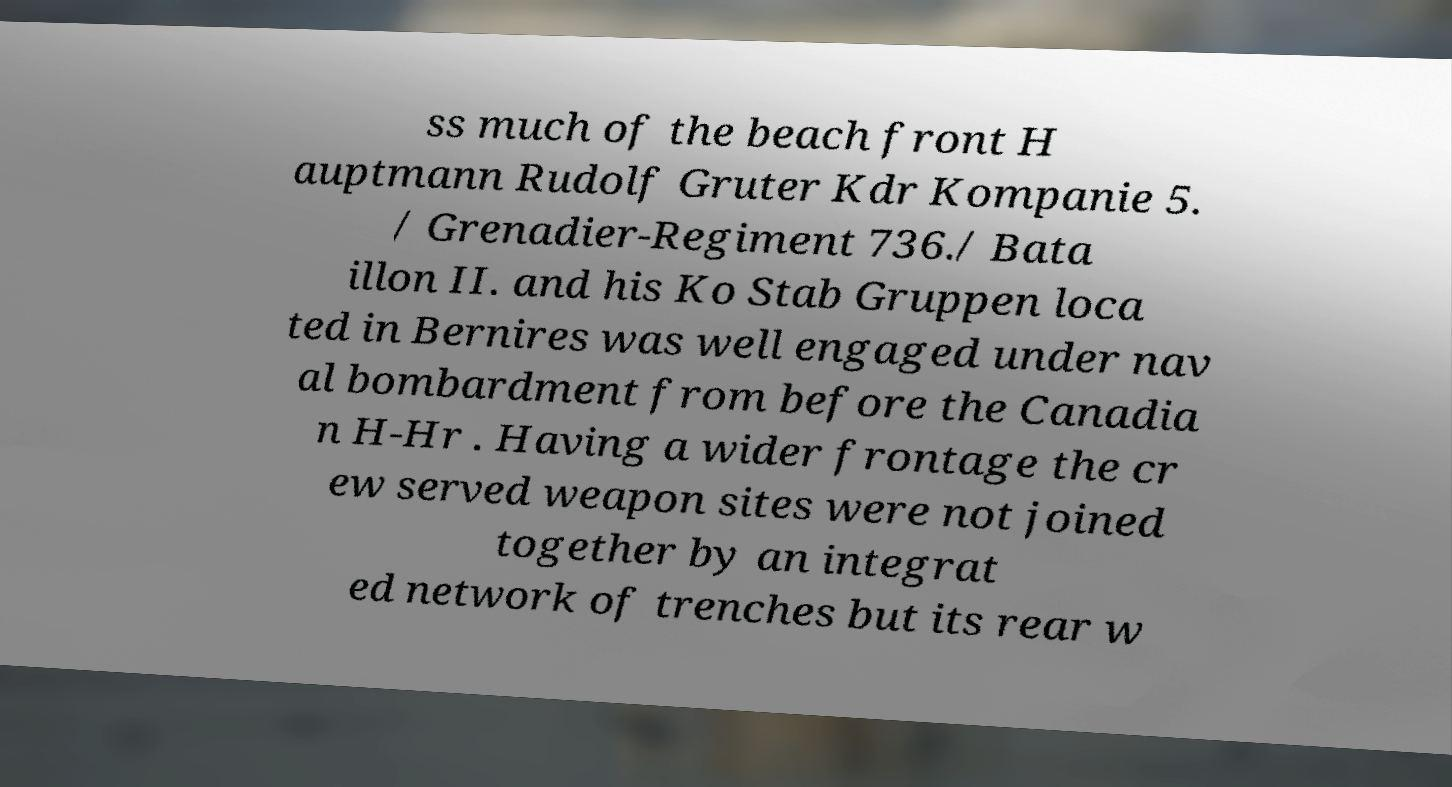Please read and relay the text visible in this image. What does it say? ss much of the beach front H auptmann Rudolf Gruter Kdr Kompanie 5. / Grenadier-Regiment 736./ Bata illon II. and his Ko Stab Gruppen loca ted in Bernires was well engaged under nav al bombardment from before the Canadia n H-Hr . Having a wider frontage the cr ew served weapon sites were not joined together by an integrat ed network of trenches but its rear w 